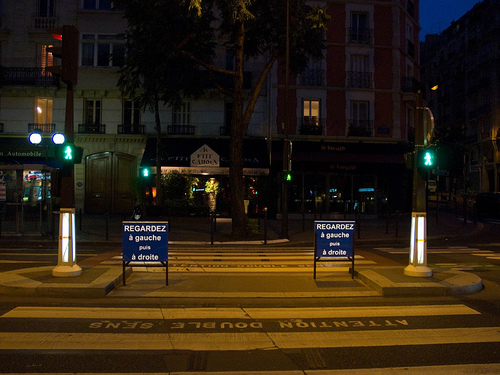Read all the text in this image. REGARDEZ GUACHE droico REGARDEZ SENS DOUBLE ATTENTION Automobile dralte 